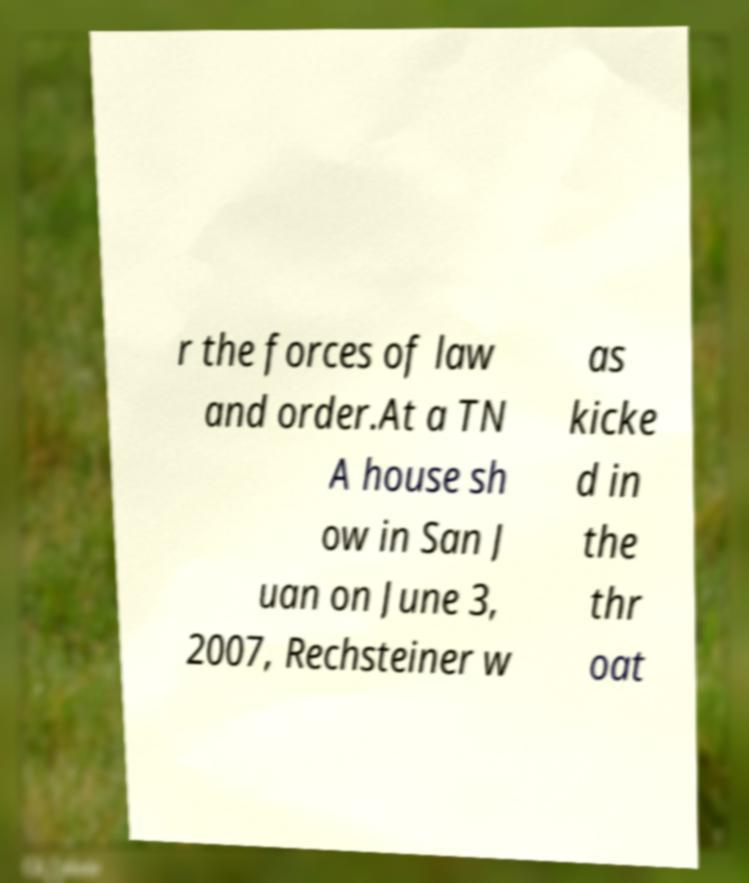There's text embedded in this image that I need extracted. Can you transcribe it verbatim? r the forces of law and order.At a TN A house sh ow in San J uan on June 3, 2007, Rechsteiner w as kicke d in the thr oat 